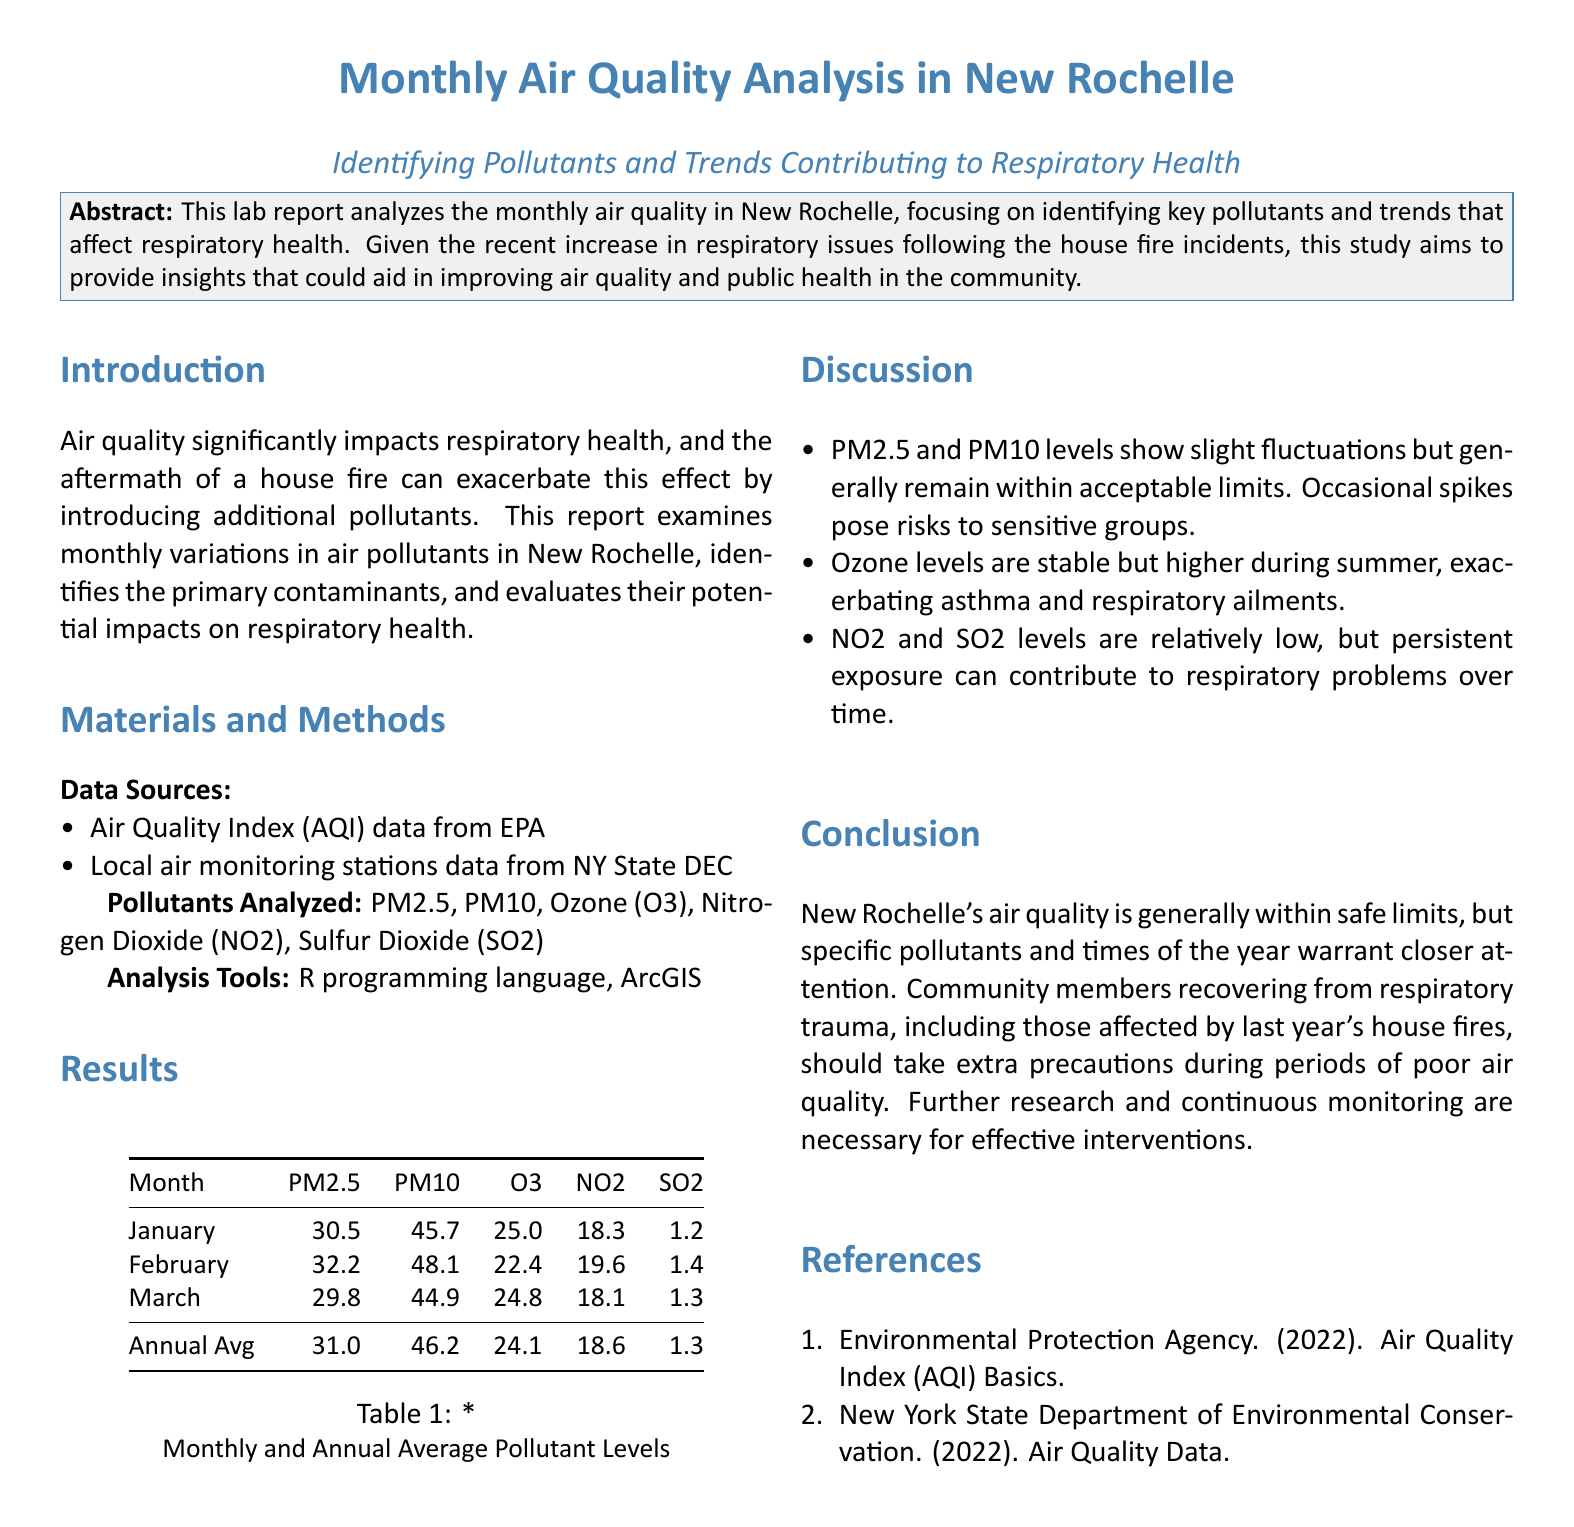What is the main focus of the report? The report focuses on identifying key pollutants and trends that affect respiratory health in New Rochelle.
Answer: Identifying pollutants and trends affecting respiratory health What is the annual average level of PM2.5? The annual average level is calculated from the monthly data presented, which is 31.0.
Answer: 31.0 What two data sources were used in this analysis? The document lists AQI data from EPA and local air monitoring stations data from NY State DEC as sources.
Answer: AQI data from EPA and local air monitoring stations data from NY State DEC Which pollutant levels are noted to be stable but higher during summer? The discussion mentions that ozone levels are stable but higher during summer.
Answer: Ozone What is one specific recommendation for community members recovering from respiratory trauma? The conclusion states that community members should take extra precautions during periods of poor air quality.
Answer: Take extra precautions during poor air quality What is the highest recorded level of PM10 in the presented data? The maximum recorded level of PM10 from the monthly data is 48.1 in February.
Answer: 48.1 Which pollutants are mentioned as relatively low but can contribute to respiratory problems over time? The document specifies NO2 and SO2 levels as relatively low but concerning over time.
Answer: NO2 and SO2 What year did the referenced house fire incidents occur? The document refers to the house fire incidents that affected residents, but a specific year isn't provided except for mentioning "last year."
Answer: Last year 